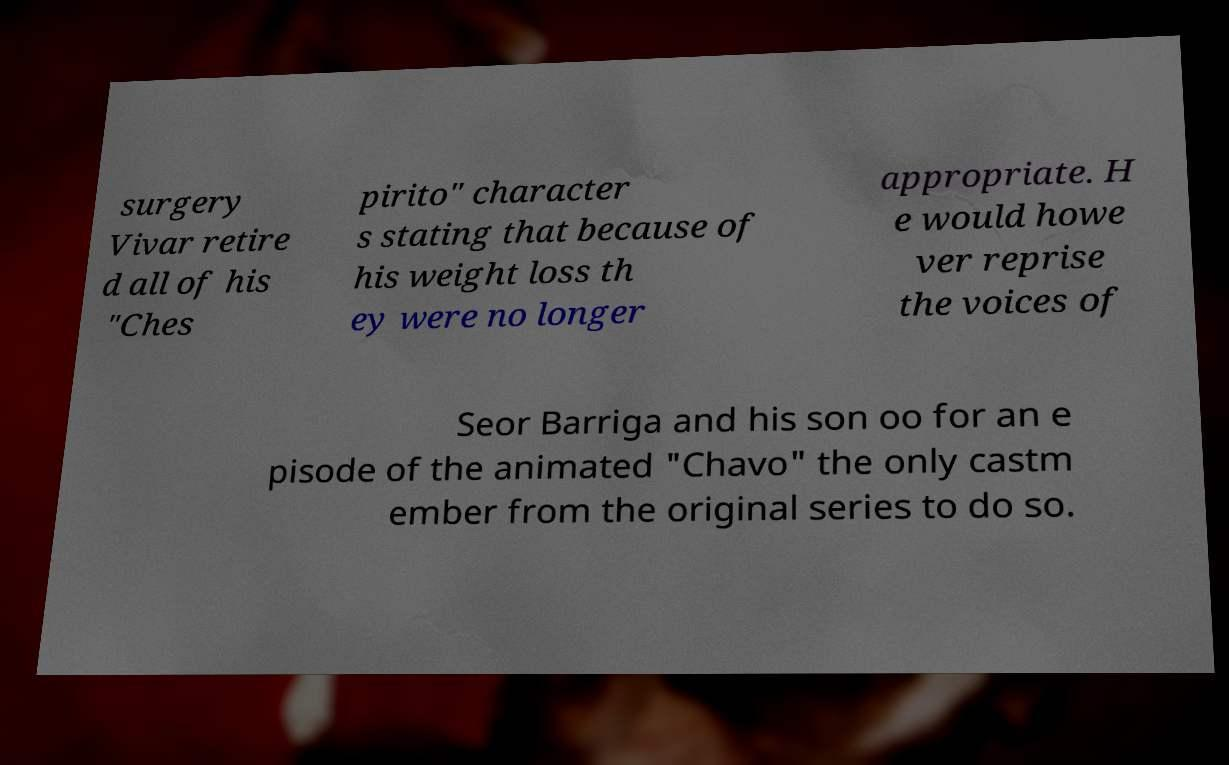What messages or text are displayed in this image? I need them in a readable, typed format. surgery Vivar retire d all of his "Ches pirito" character s stating that because of his weight loss th ey were no longer appropriate. H e would howe ver reprise the voices of Seor Barriga and his son oo for an e pisode of the animated "Chavo" the only castm ember from the original series to do so. 